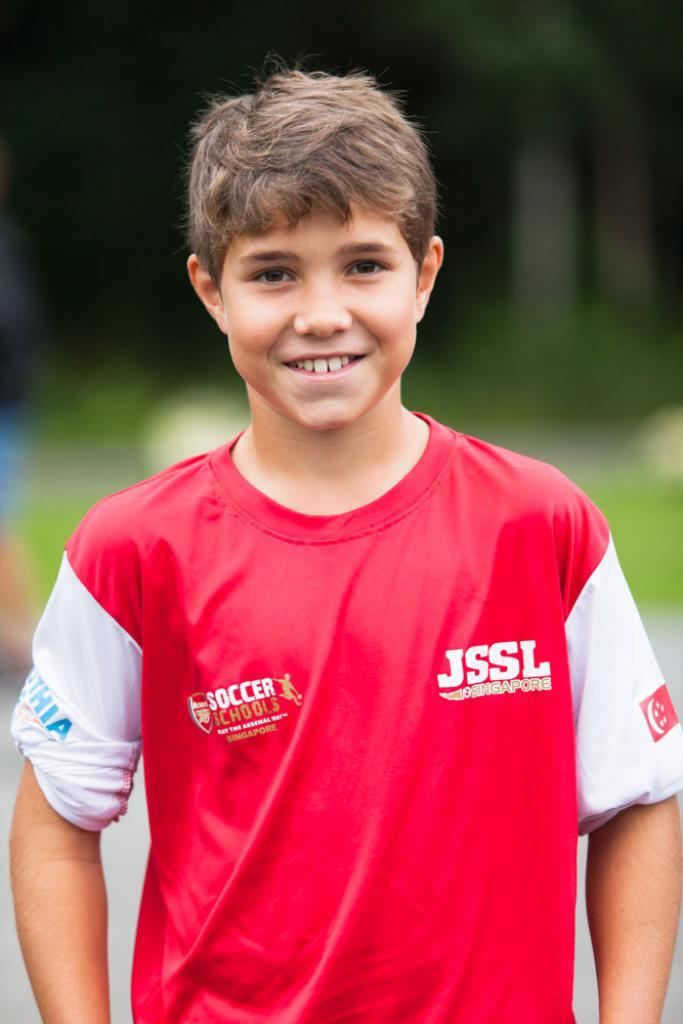<image>
Give a short and clear explanation of the subsequent image. a boy is smiling while wearing a JSSL soccer jersey 